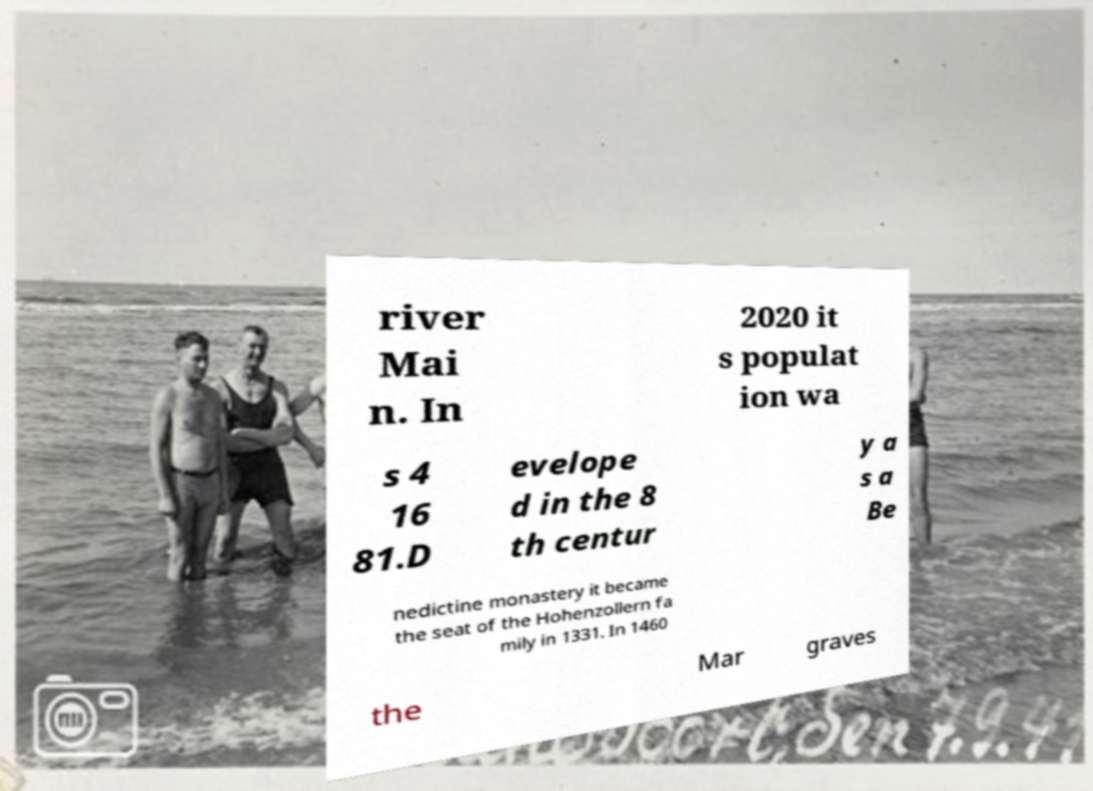There's text embedded in this image that I need extracted. Can you transcribe it verbatim? river Mai n. In 2020 it s populat ion wa s 4 16 81.D evelope d in the 8 th centur y a s a Be nedictine monastery it became the seat of the Hohenzollern fa mily in 1331. In 1460 the Mar graves 